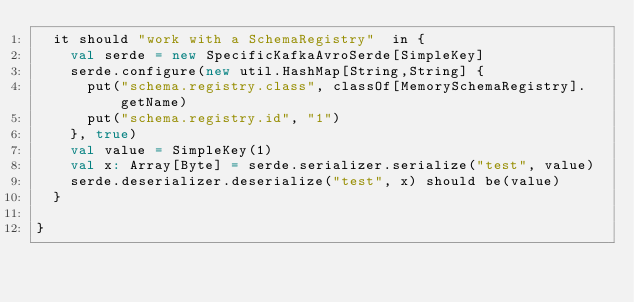Convert code to text. <code><loc_0><loc_0><loc_500><loc_500><_Scala_>  it should "work with a SchemaRegistry"  in {
    val serde = new SpecificKafkaAvroSerde[SimpleKey]
    serde.configure(new util.HashMap[String,String] {
      put("schema.registry.class", classOf[MemorySchemaRegistry].getName)
      put("schema.registry.id", "1")
    }, true)
    val value = SimpleKey(1)
    val x: Array[Byte] = serde.serializer.serialize("test", value)
    serde.deserializer.deserialize("test", x) should be(value)
  }

}
</code> 